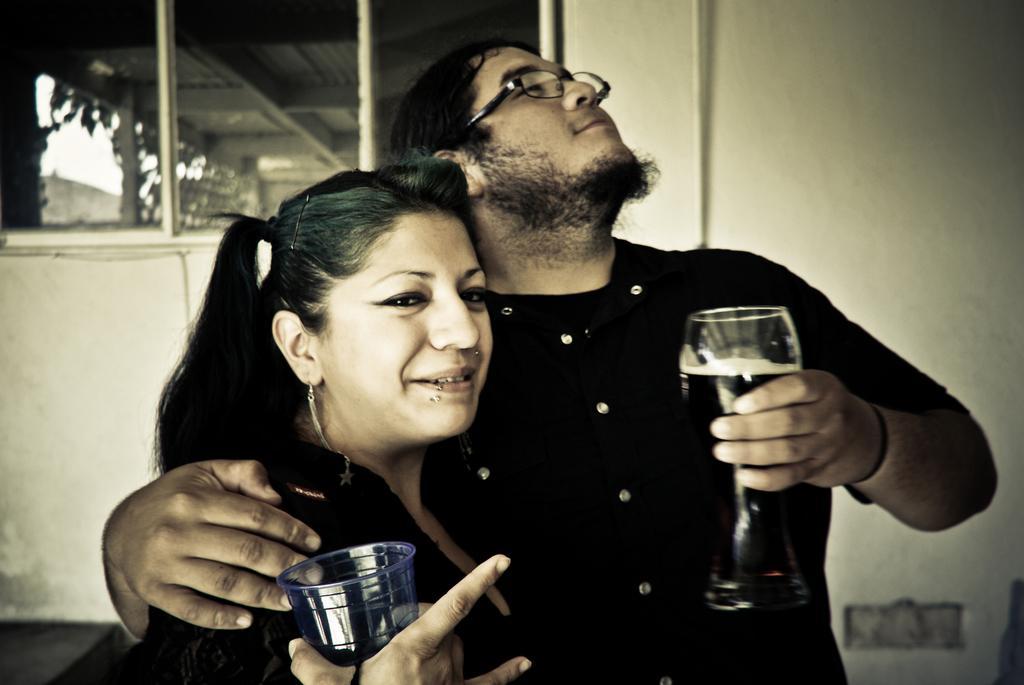In one or two sentences, can you explain what this image depicts? On the background we can see a wall and windows. We can see a man and woman holding glasses in their hands. This man wore spectacles. 